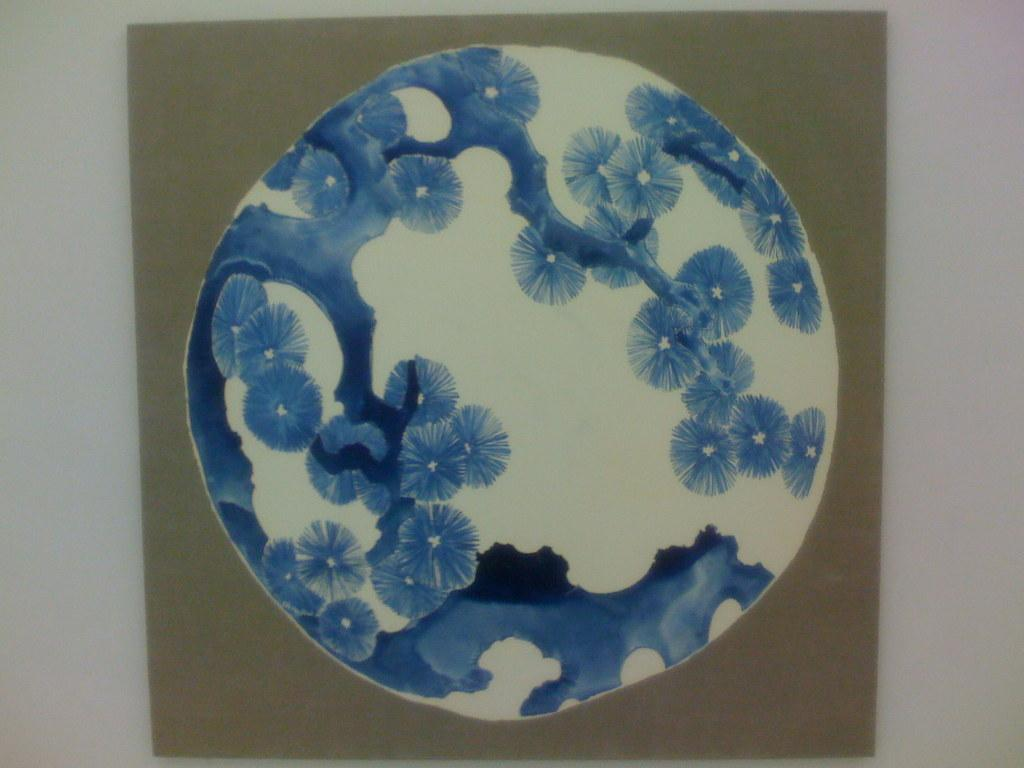What is present on the cardboard sheet in the image? There is a plate on the cardboard sheet in the image. What type of bat is hanging from the plate in the image? There is no bat present in the image; it only features a plate on a cardboard sheet. 